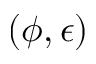<formula> <loc_0><loc_0><loc_500><loc_500>( \phi , \epsilon )</formula> 